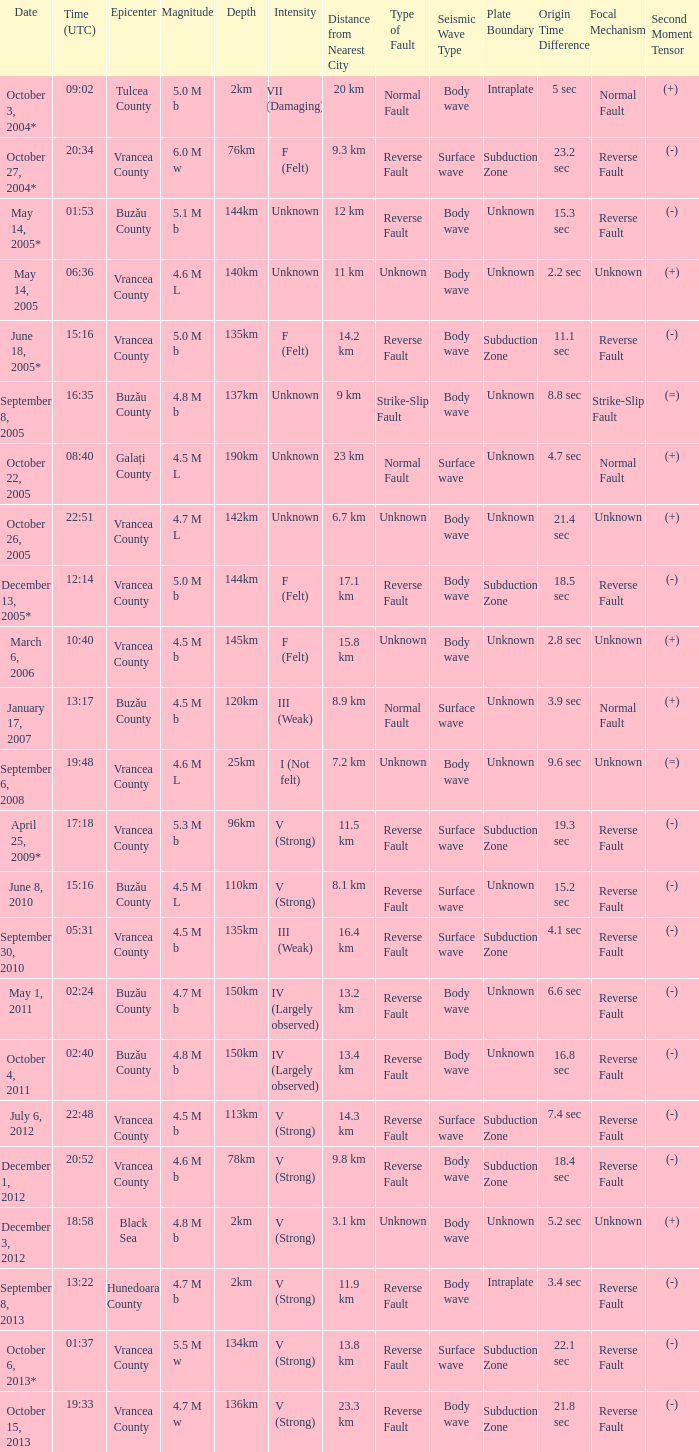What is the magnitude with epicenter at Vrancea County, unknown intensity and which happened at 06:36? 4.6 M L. 